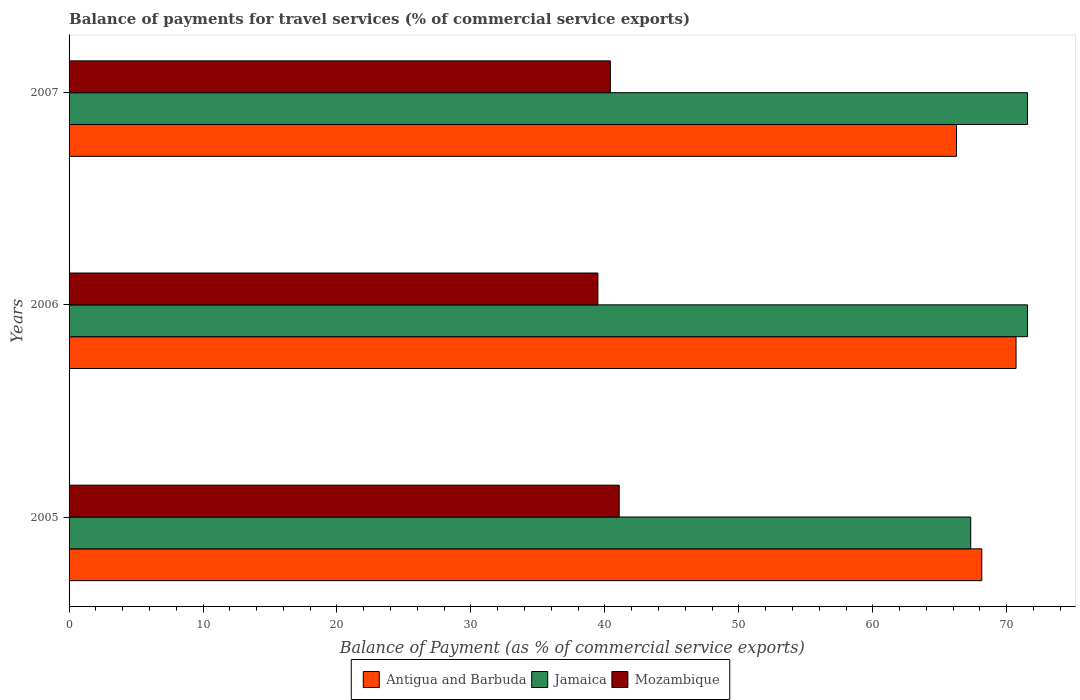How many different coloured bars are there?
Your answer should be very brief. 3. How many groups of bars are there?
Offer a terse response. 3. How many bars are there on the 2nd tick from the bottom?
Offer a very short reply. 3. What is the label of the 1st group of bars from the top?
Provide a short and direct response. 2007. In how many cases, is the number of bars for a given year not equal to the number of legend labels?
Make the answer very short. 0. What is the balance of payments for travel services in Jamaica in 2007?
Offer a terse response. 71.55. Across all years, what is the maximum balance of payments for travel services in Mozambique?
Make the answer very short. 41.07. Across all years, what is the minimum balance of payments for travel services in Mozambique?
Give a very brief answer. 39.48. What is the total balance of payments for travel services in Mozambique in the graph?
Your answer should be compact. 120.96. What is the difference between the balance of payments for travel services in Mozambique in 2005 and that in 2006?
Your answer should be compact. 1.59. What is the difference between the balance of payments for travel services in Antigua and Barbuda in 2005 and the balance of payments for travel services in Mozambique in 2007?
Provide a short and direct response. 27.73. What is the average balance of payments for travel services in Antigua and Barbuda per year?
Provide a succinct answer. 68.36. In the year 2006, what is the difference between the balance of payments for travel services in Mozambique and balance of payments for travel services in Antigua and Barbuda?
Your answer should be very brief. -31.21. In how many years, is the balance of payments for travel services in Mozambique greater than 40 %?
Provide a short and direct response. 2. What is the ratio of the balance of payments for travel services in Jamaica in 2006 to that in 2007?
Provide a short and direct response. 1. Is the difference between the balance of payments for travel services in Mozambique in 2006 and 2007 greater than the difference between the balance of payments for travel services in Antigua and Barbuda in 2006 and 2007?
Provide a succinct answer. No. What is the difference between the highest and the second highest balance of payments for travel services in Jamaica?
Offer a very short reply. 0.01. What is the difference between the highest and the lowest balance of payments for travel services in Jamaica?
Make the answer very short. 4.24. Is the sum of the balance of payments for travel services in Mozambique in 2006 and 2007 greater than the maximum balance of payments for travel services in Jamaica across all years?
Offer a very short reply. Yes. What does the 3rd bar from the top in 2005 represents?
Provide a succinct answer. Antigua and Barbuda. What does the 2nd bar from the bottom in 2007 represents?
Give a very brief answer. Jamaica. How many bars are there?
Your answer should be very brief. 9. How many years are there in the graph?
Provide a short and direct response. 3. What is the difference between two consecutive major ticks on the X-axis?
Make the answer very short. 10. Does the graph contain grids?
Give a very brief answer. No. Where does the legend appear in the graph?
Give a very brief answer. Bottom center. How many legend labels are there?
Keep it short and to the point. 3. How are the legend labels stacked?
Provide a short and direct response. Horizontal. What is the title of the graph?
Ensure brevity in your answer.  Balance of payments for travel services (% of commercial service exports). Does "Middle East & North Africa (developing only)" appear as one of the legend labels in the graph?
Your response must be concise. No. What is the label or title of the X-axis?
Your response must be concise. Balance of Payment (as % of commercial service exports). What is the Balance of Payment (as % of commercial service exports) in Antigua and Barbuda in 2005?
Your response must be concise. 68.14. What is the Balance of Payment (as % of commercial service exports) in Jamaica in 2005?
Make the answer very short. 67.31. What is the Balance of Payment (as % of commercial service exports) of Mozambique in 2005?
Your answer should be very brief. 41.07. What is the Balance of Payment (as % of commercial service exports) of Antigua and Barbuda in 2006?
Provide a short and direct response. 70.69. What is the Balance of Payment (as % of commercial service exports) of Jamaica in 2006?
Give a very brief answer. 71.55. What is the Balance of Payment (as % of commercial service exports) of Mozambique in 2006?
Keep it short and to the point. 39.48. What is the Balance of Payment (as % of commercial service exports) of Antigua and Barbuda in 2007?
Make the answer very short. 66.25. What is the Balance of Payment (as % of commercial service exports) of Jamaica in 2007?
Give a very brief answer. 71.55. What is the Balance of Payment (as % of commercial service exports) of Mozambique in 2007?
Provide a short and direct response. 40.41. Across all years, what is the maximum Balance of Payment (as % of commercial service exports) of Antigua and Barbuda?
Your answer should be compact. 70.69. Across all years, what is the maximum Balance of Payment (as % of commercial service exports) in Jamaica?
Make the answer very short. 71.55. Across all years, what is the maximum Balance of Payment (as % of commercial service exports) of Mozambique?
Your answer should be compact. 41.07. Across all years, what is the minimum Balance of Payment (as % of commercial service exports) in Antigua and Barbuda?
Give a very brief answer. 66.25. Across all years, what is the minimum Balance of Payment (as % of commercial service exports) in Jamaica?
Make the answer very short. 67.31. Across all years, what is the minimum Balance of Payment (as % of commercial service exports) of Mozambique?
Keep it short and to the point. 39.48. What is the total Balance of Payment (as % of commercial service exports) of Antigua and Barbuda in the graph?
Offer a terse response. 205.08. What is the total Balance of Payment (as % of commercial service exports) of Jamaica in the graph?
Provide a short and direct response. 210.41. What is the total Balance of Payment (as % of commercial service exports) of Mozambique in the graph?
Provide a succinct answer. 120.96. What is the difference between the Balance of Payment (as % of commercial service exports) of Antigua and Barbuda in 2005 and that in 2006?
Provide a short and direct response. -2.56. What is the difference between the Balance of Payment (as % of commercial service exports) of Jamaica in 2005 and that in 2006?
Your answer should be very brief. -4.24. What is the difference between the Balance of Payment (as % of commercial service exports) in Mozambique in 2005 and that in 2006?
Provide a short and direct response. 1.59. What is the difference between the Balance of Payment (as % of commercial service exports) in Antigua and Barbuda in 2005 and that in 2007?
Keep it short and to the point. 1.89. What is the difference between the Balance of Payment (as % of commercial service exports) in Jamaica in 2005 and that in 2007?
Give a very brief answer. -4.24. What is the difference between the Balance of Payment (as % of commercial service exports) in Mozambique in 2005 and that in 2007?
Keep it short and to the point. 0.66. What is the difference between the Balance of Payment (as % of commercial service exports) of Antigua and Barbuda in 2006 and that in 2007?
Keep it short and to the point. 4.44. What is the difference between the Balance of Payment (as % of commercial service exports) in Jamaica in 2006 and that in 2007?
Keep it short and to the point. 0.01. What is the difference between the Balance of Payment (as % of commercial service exports) in Mozambique in 2006 and that in 2007?
Ensure brevity in your answer.  -0.93. What is the difference between the Balance of Payment (as % of commercial service exports) in Antigua and Barbuda in 2005 and the Balance of Payment (as % of commercial service exports) in Jamaica in 2006?
Make the answer very short. -3.42. What is the difference between the Balance of Payment (as % of commercial service exports) of Antigua and Barbuda in 2005 and the Balance of Payment (as % of commercial service exports) of Mozambique in 2006?
Keep it short and to the point. 28.66. What is the difference between the Balance of Payment (as % of commercial service exports) in Jamaica in 2005 and the Balance of Payment (as % of commercial service exports) in Mozambique in 2006?
Ensure brevity in your answer.  27.83. What is the difference between the Balance of Payment (as % of commercial service exports) in Antigua and Barbuda in 2005 and the Balance of Payment (as % of commercial service exports) in Jamaica in 2007?
Your answer should be very brief. -3.41. What is the difference between the Balance of Payment (as % of commercial service exports) in Antigua and Barbuda in 2005 and the Balance of Payment (as % of commercial service exports) in Mozambique in 2007?
Your answer should be compact. 27.73. What is the difference between the Balance of Payment (as % of commercial service exports) of Jamaica in 2005 and the Balance of Payment (as % of commercial service exports) of Mozambique in 2007?
Give a very brief answer. 26.9. What is the difference between the Balance of Payment (as % of commercial service exports) of Antigua and Barbuda in 2006 and the Balance of Payment (as % of commercial service exports) of Jamaica in 2007?
Provide a short and direct response. -0.85. What is the difference between the Balance of Payment (as % of commercial service exports) of Antigua and Barbuda in 2006 and the Balance of Payment (as % of commercial service exports) of Mozambique in 2007?
Keep it short and to the point. 30.29. What is the difference between the Balance of Payment (as % of commercial service exports) in Jamaica in 2006 and the Balance of Payment (as % of commercial service exports) in Mozambique in 2007?
Your response must be concise. 31.15. What is the average Balance of Payment (as % of commercial service exports) in Antigua and Barbuda per year?
Make the answer very short. 68.36. What is the average Balance of Payment (as % of commercial service exports) of Jamaica per year?
Offer a very short reply. 70.14. What is the average Balance of Payment (as % of commercial service exports) in Mozambique per year?
Ensure brevity in your answer.  40.32. In the year 2005, what is the difference between the Balance of Payment (as % of commercial service exports) of Antigua and Barbuda and Balance of Payment (as % of commercial service exports) of Jamaica?
Give a very brief answer. 0.83. In the year 2005, what is the difference between the Balance of Payment (as % of commercial service exports) in Antigua and Barbuda and Balance of Payment (as % of commercial service exports) in Mozambique?
Your answer should be compact. 27.07. In the year 2005, what is the difference between the Balance of Payment (as % of commercial service exports) of Jamaica and Balance of Payment (as % of commercial service exports) of Mozambique?
Offer a terse response. 26.24. In the year 2006, what is the difference between the Balance of Payment (as % of commercial service exports) of Antigua and Barbuda and Balance of Payment (as % of commercial service exports) of Jamaica?
Provide a short and direct response. -0.86. In the year 2006, what is the difference between the Balance of Payment (as % of commercial service exports) in Antigua and Barbuda and Balance of Payment (as % of commercial service exports) in Mozambique?
Give a very brief answer. 31.21. In the year 2006, what is the difference between the Balance of Payment (as % of commercial service exports) of Jamaica and Balance of Payment (as % of commercial service exports) of Mozambique?
Your answer should be very brief. 32.07. In the year 2007, what is the difference between the Balance of Payment (as % of commercial service exports) of Antigua and Barbuda and Balance of Payment (as % of commercial service exports) of Jamaica?
Give a very brief answer. -5.3. In the year 2007, what is the difference between the Balance of Payment (as % of commercial service exports) of Antigua and Barbuda and Balance of Payment (as % of commercial service exports) of Mozambique?
Give a very brief answer. 25.84. In the year 2007, what is the difference between the Balance of Payment (as % of commercial service exports) in Jamaica and Balance of Payment (as % of commercial service exports) in Mozambique?
Your response must be concise. 31.14. What is the ratio of the Balance of Payment (as % of commercial service exports) in Antigua and Barbuda in 2005 to that in 2006?
Your answer should be compact. 0.96. What is the ratio of the Balance of Payment (as % of commercial service exports) in Jamaica in 2005 to that in 2006?
Your answer should be very brief. 0.94. What is the ratio of the Balance of Payment (as % of commercial service exports) in Mozambique in 2005 to that in 2006?
Give a very brief answer. 1.04. What is the ratio of the Balance of Payment (as % of commercial service exports) of Antigua and Barbuda in 2005 to that in 2007?
Offer a very short reply. 1.03. What is the ratio of the Balance of Payment (as % of commercial service exports) of Jamaica in 2005 to that in 2007?
Ensure brevity in your answer.  0.94. What is the ratio of the Balance of Payment (as % of commercial service exports) in Mozambique in 2005 to that in 2007?
Give a very brief answer. 1.02. What is the ratio of the Balance of Payment (as % of commercial service exports) in Antigua and Barbuda in 2006 to that in 2007?
Provide a short and direct response. 1.07. What is the ratio of the Balance of Payment (as % of commercial service exports) of Jamaica in 2006 to that in 2007?
Your answer should be very brief. 1. What is the ratio of the Balance of Payment (as % of commercial service exports) of Mozambique in 2006 to that in 2007?
Keep it short and to the point. 0.98. What is the difference between the highest and the second highest Balance of Payment (as % of commercial service exports) of Antigua and Barbuda?
Give a very brief answer. 2.56. What is the difference between the highest and the second highest Balance of Payment (as % of commercial service exports) of Jamaica?
Ensure brevity in your answer.  0.01. What is the difference between the highest and the second highest Balance of Payment (as % of commercial service exports) in Mozambique?
Keep it short and to the point. 0.66. What is the difference between the highest and the lowest Balance of Payment (as % of commercial service exports) of Antigua and Barbuda?
Keep it short and to the point. 4.44. What is the difference between the highest and the lowest Balance of Payment (as % of commercial service exports) of Jamaica?
Offer a very short reply. 4.24. What is the difference between the highest and the lowest Balance of Payment (as % of commercial service exports) in Mozambique?
Provide a short and direct response. 1.59. 